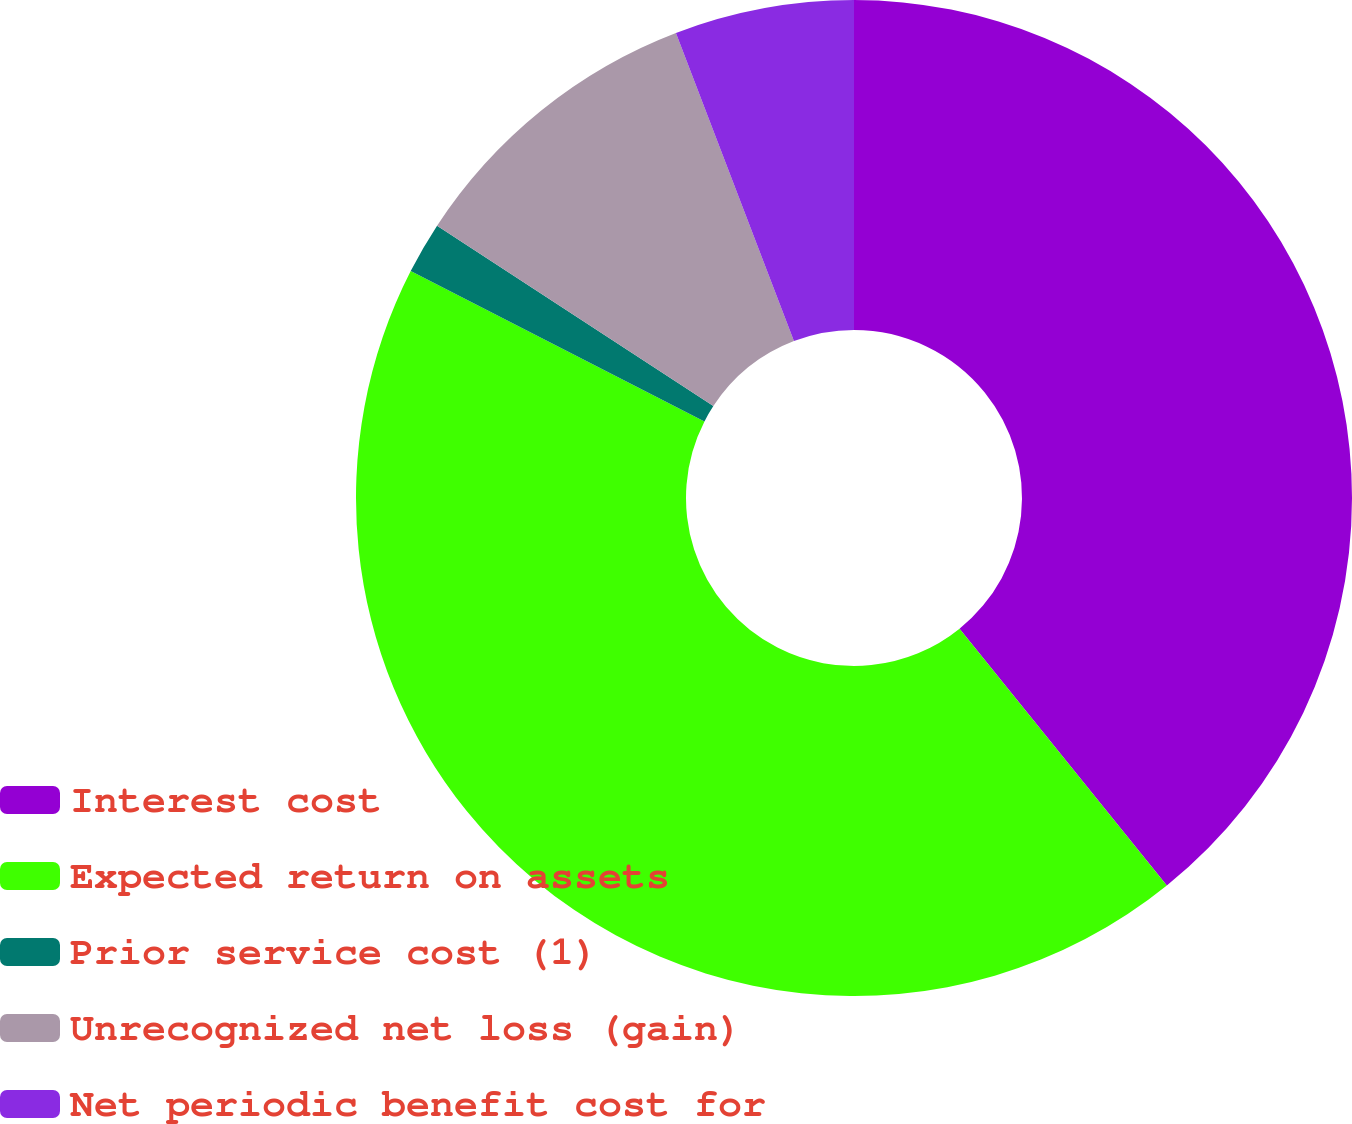<chart> <loc_0><loc_0><loc_500><loc_500><pie_chart><fcel>Interest cost<fcel>Expected return on assets<fcel>Prior service cost (1)<fcel>Unrecognized net loss (gain)<fcel>Net periodic benefit cost for<nl><fcel>39.19%<fcel>43.34%<fcel>1.68%<fcel>9.97%<fcel>5.82%<nl></chart> 